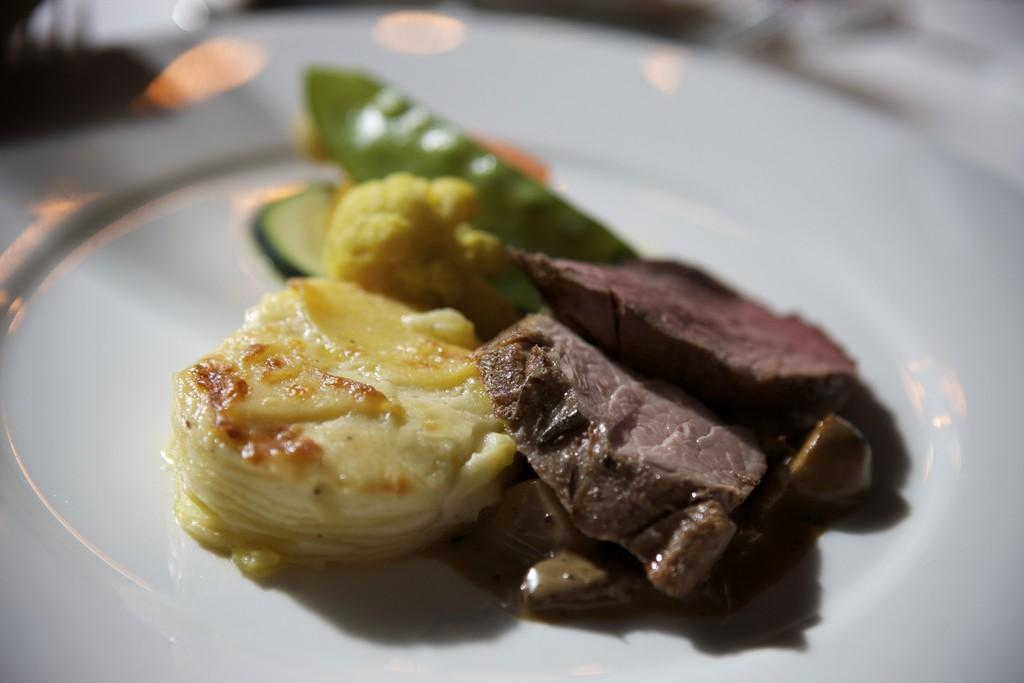What is present on the plate in the image? There are food items in a plate in the image. Can you describe the popcorn detail in the image? There is no popcorn present in the image. 